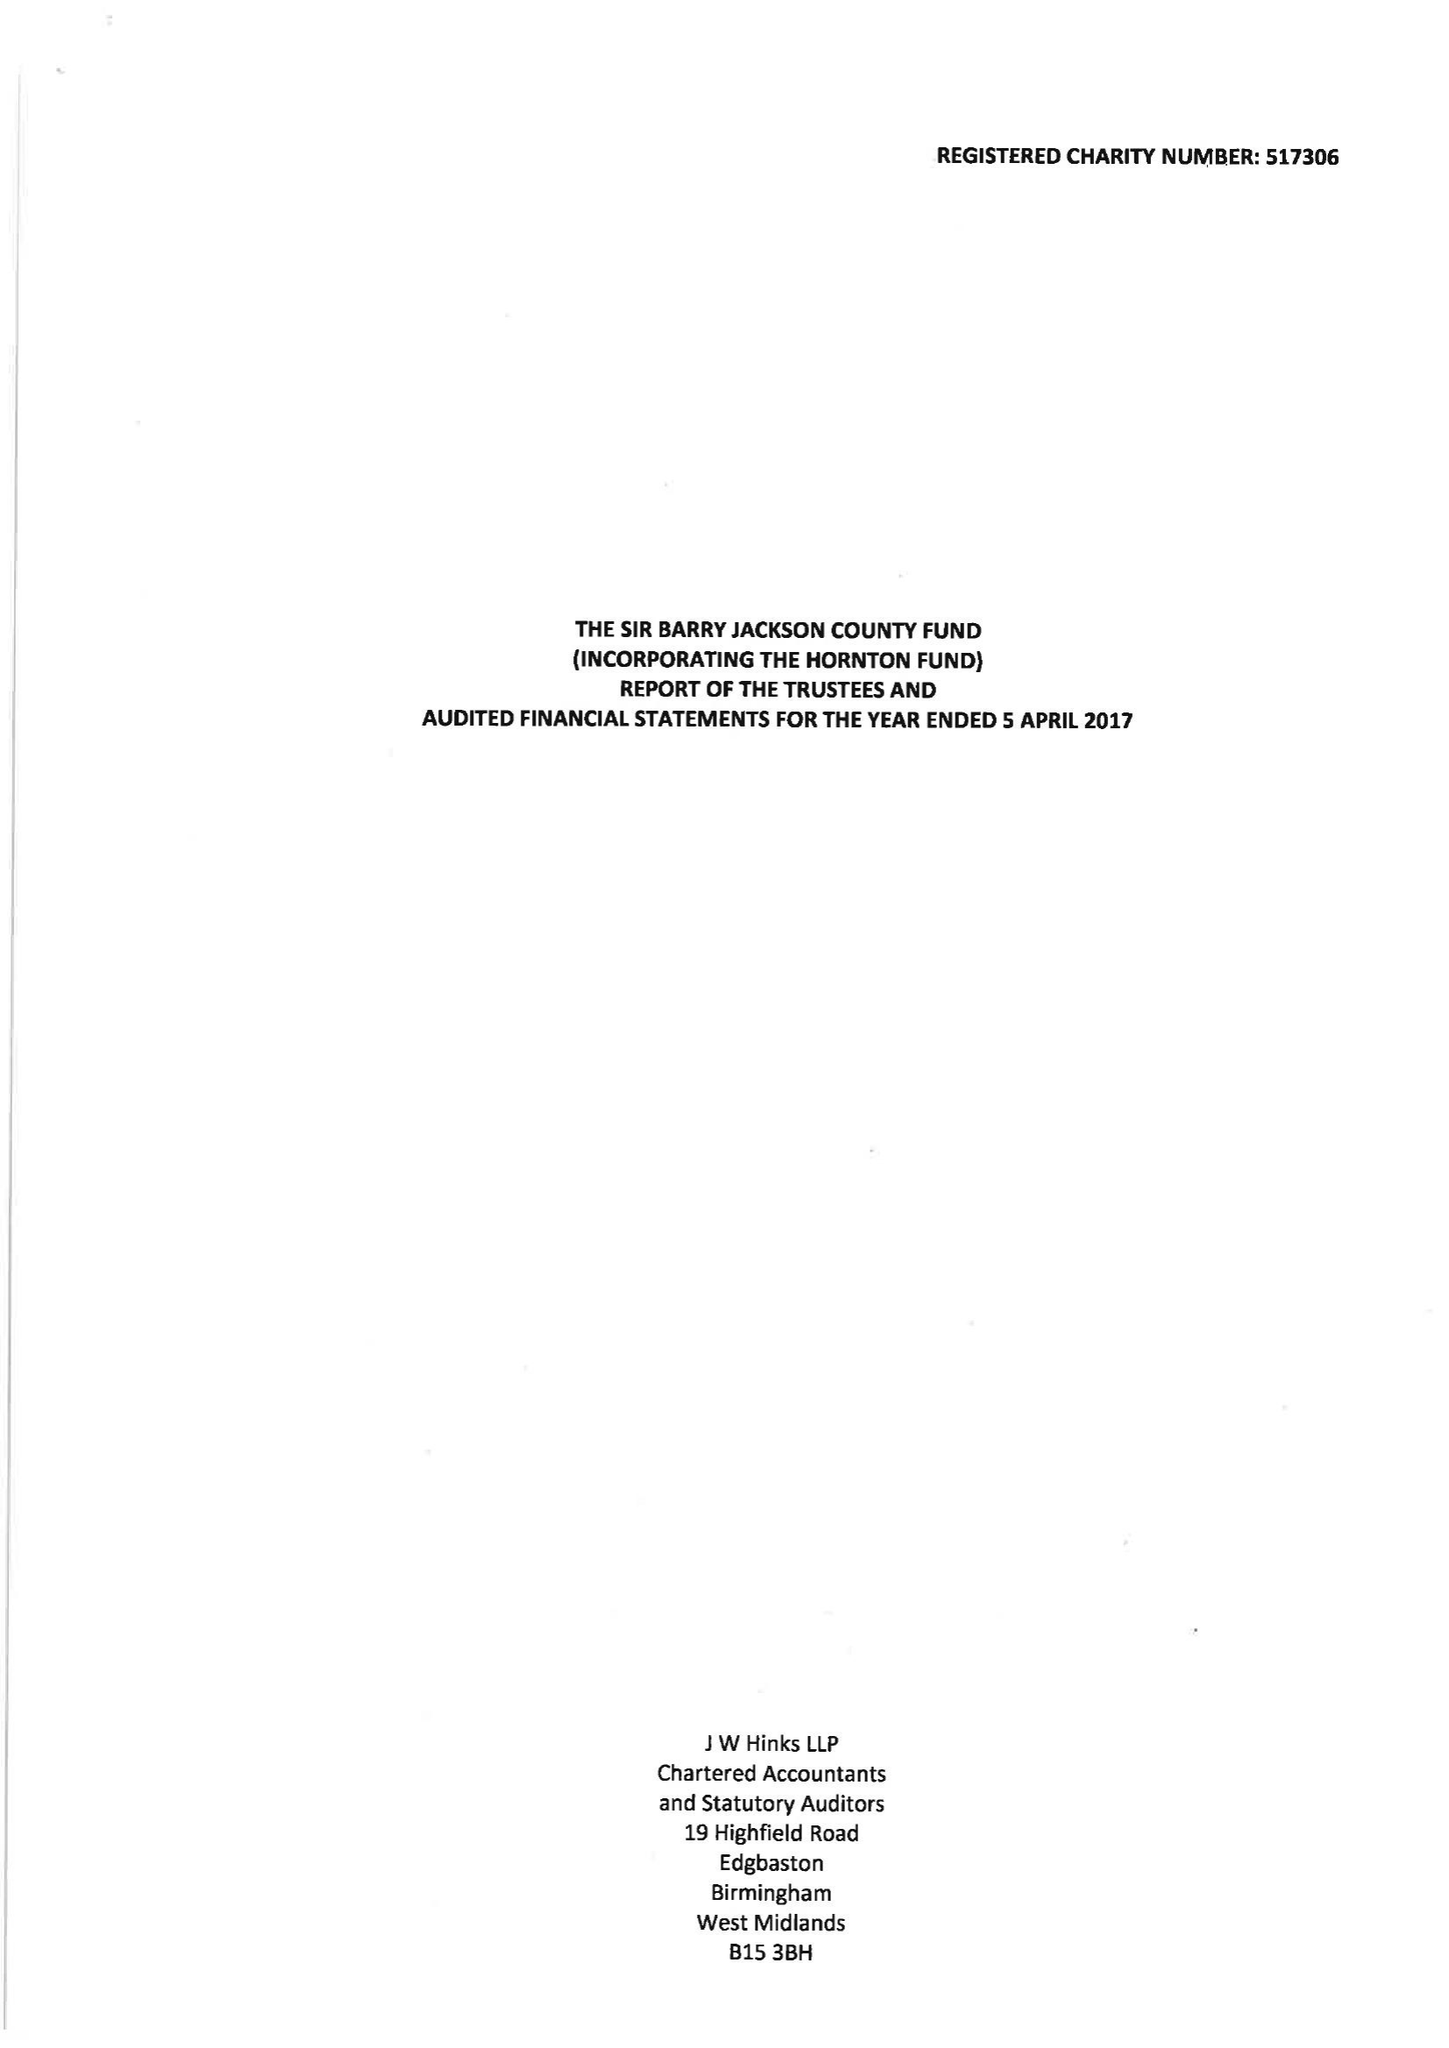What is the value for the spending_annually_in_british_pounds?
Answer the question using a single word or phrase. 100525.00 